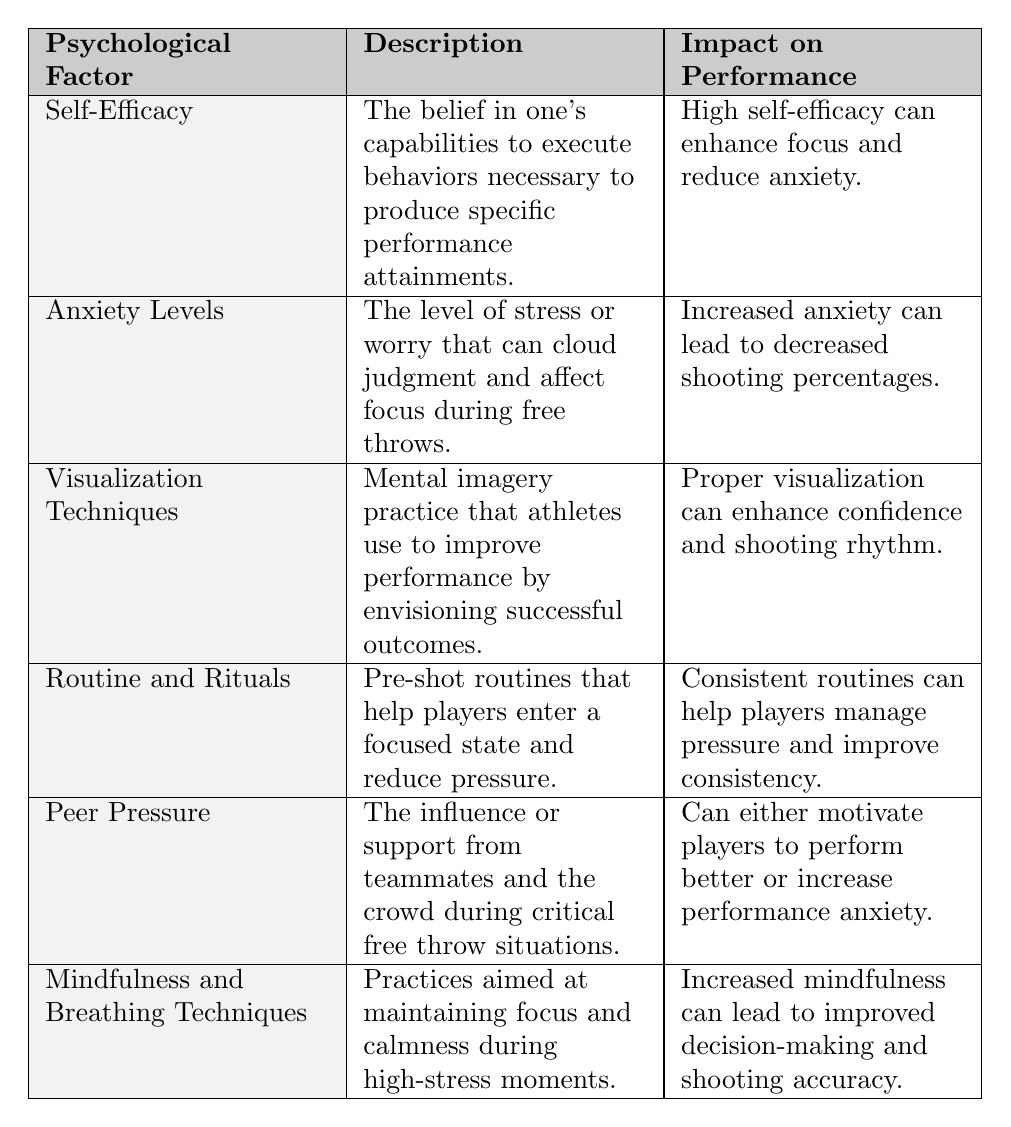What psychological factor is associated with decreased shooting percentages? The table lists "Anxiety Levels" as a psychological factor that leads to decreased shooting percentages when increased.
Answer: Anxiety Levels Which psychological factor is linked to enhancing focus and reducing anxiety? According to the table, "Self-Efficacy" is noted to enhance focus and reduce anxiety.
Answer: Self-Efficacy Name one example of how visualization techniques are used by players. The table provides examples stating that "Kobe Bryant was known for his visualization techniques before games," showcasing a player's use of these techniques.
Answer: Kobe Bryant True or False: Mindfulness and breathing techniques can lead to improved decision-making. The table states that increased mindfulness can enhance decision-making, making the statement true.
Answer: True Which factors can impact performance positively? List them. Factors that can positively impact performance include "Self-Efficacy," "Visualization Techniques," "Routine and Rituals," and "Mindfulness and Breathing Techniques," as these factors are described to enhance focus and shooting accuracy.
Answer: Self-Efficacy, Visualization Techniques, Routine and Rituals, Mindfulness and Breathing Techniques How do peer pressure effects differ in free throw situations? The table describes peer pressure as having dual effects: it can motivate players to perform better or increase performance anxiety, indicating differing impacts based on the situation.
Answer: It can motivate or increase anxiety What is the relationship between anxiety levels and performance? The table notes that increased anxiety directly correlates with decreased shooting percentages, establishing a negative relationship.
Answer: Increased anxiety decreases performance Which psychological factor involves pre-shot routines? "Routine and Rituals" is the psychological factor related to pre-shot routines as described in the table.
Answer: Routine and Rituals Which two psychological factors specifically mention enhancing confidence? "Self-Efficacy" and "Visualization Techniques" are both highlighted in the table for their roles in enhancing confidence during free throws.
Answer: Self-Efficacy, Visualization Techniques What can be concluded about the impact of routine and rituals on performance? The table states that consistent routines can help players manage pressure and improve their shooting consistency, culminating in a positive impact on performance.
Answer: They improve performance under pressure 